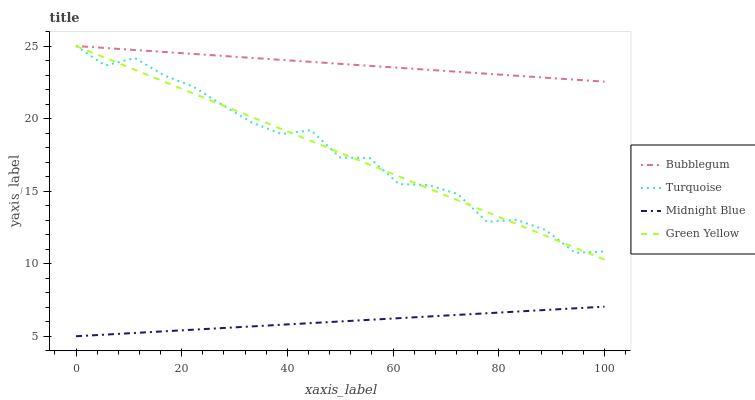Does Midnight Blue have the minimum area under the curve?
Answer yes or no. Yes. Does Bubblegum have the maximum area under the curve?
Answer yes or no. Yes. Does Green Yellow have the minimum area under the curve?
Answer yes or no. No. Does Green Yellow have the maximum area under the curve?
Answer yes or no. No. Is Midnight Blue the smoothest?
Answer yes or no. Yes. Is Turquoise the roughest?
Answer yes or no. Yes. Is Green Yellow the smoothest?
Answer yes or no. No. Is Green Yellow the roughest?
Answer yes or no. No. Does Green Yellow have the lowest value?
Answer yes or no. No. Does Bubblegum have the highest value?
Answer yes or no. Yes. Does Midnight Blue have the highest value?
Answer yes or no. No. Is Midnight Blue less than Bubblegum?
Answer yes or no. Yes. Is Turquoise greater than Midnight Blue?
Answer yes or no. Yes. Does Green Yellow intersect Bubblegum?
Answer yes or no. Yes. Is Green Yellow less than Bubblegum?
Answer yes or no. No. Is Green Yellow greater than Bubblegum?
Answer yes or no. No. Does Midnight Blue intersect Bubblegum?
Answer yes or no. No. 